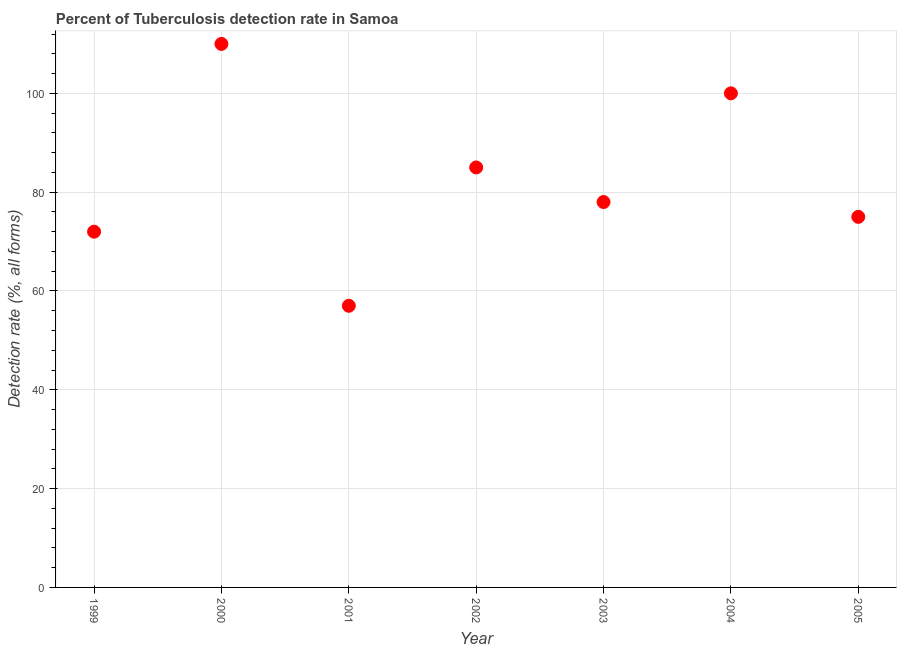What is the detection rate of tuberculosis in 2005?
Make the answer very short. 75. Across all years, what is the maximum detection rate of tuberculosis?
Provide a short and direct response. 110. Across all years, what is the minimum detection rate of tuberculosis?
Provide a short and direct response. 57. In which year was the detection rate of tuberculosis minimum?
Provide a short and direct response. 2001. What is the sum of the detection rate of tuberculosis?
Your answer should be compact. 577. What is the difference between the detection rate of tuberculosis in 1999 and 2002?
Make the answer very short. -13. What is the average detection rate of tuberculosis per year?
Offer a terse response. 82.43. Do a majority of the years between 2001 and 2000 (inclusive) have detection rate of tuberculosis greater than 44 %?
Offer a terse response. No. What is the ratio of the detection rate of tuberculosis in 2000 to that in 2002?
Offer a very short reply. 1.29. What is the difference between the highest and the second highest detection rate of tuberculosis?
Your response must be concise. 10. What is the difference between the highest and the lowest detection rate of tuberculosis?
Offer a very short reply. 53. How many dotlines are there?
Make the answer very short. 1. What is the difference between two consecutive major ticks on the Y-axis?
Your response must be concise. 20. Are the values on the major ticks of Y-axis written in scientific E-notation?
Keep it short and to the point. No. Does the graph contain grids?
Offer a terse response. Yes. What is the title of the graph?
Offer a terse response. Percent of Tuberculosis detection rate in Samoa. What is the label or title of the X-axis?
Your response must be concise. Year. What is the label or title of the Y-axis?
Give a very brief answer. Detection rate (%, all forms). What is the Detection rate (%, all forms) in 2000?
Make the answer very short. 110. What is the Detection rate (%, all forms) in 2002?
Your answer should be compact. 85. What is the Detection rate (%, all forms) in 2003?
Make the answer very short. 78. What is the Detection rate (%, all forms) in 2004?
Offer a very short reply. 100. What is the Detection rate (%, all forms) in 2005?
Your response must be concise. 75. What is the difference between the Detection rate (%, all forms) in 1999 and 2000?
Your answer should be very brief. -38. What is the difference between the Detection rate (%, all forms) in 1999 and 2001?
Offer a very short reply. 15. What is the difference between the Detection rate (%, all forms) in 1999 and 2003?
Your answer should be compact. -6. What is the difference between the Detection rate (%, all forms) in 1999 and 2004?
Offer a very short reply. -28. What is the difference between the Detection rate (%, all forms) in 1999 and 2005?
Your answer should be very brief. -3. What is the difference between the Detection rate (%, all forms) in 2000 and 2001?
Offer a terse response. 53. What is the difference between the Detection rate (%, all forms) in 2000 and 2002?
Provide a succinct answer. 25. What is the difference between the Detection rate (%, all forms) in 2001 and 2004?
Your answer should be compact. -43. What is the difference between the Detection rate (%, all forms) in 2002 and 2004?
Give a very brief answer. -15. What is the difference between the Detection rate (%, all forms) in 2002 and 2005?
Provide a short and direct response. 10. What is the difference between the Detection rate (%, all forms) in 2003 and 2005?
Provide a succinct answer. 3. What is the ratio of the Detection rate (%, all forms) in 1999 to that in 2000?
Provide a succinct answer. 0.66. What is the ratio of the Detection rate (%, all forms) in 1999 to that in 2001?
Provide a succinct answer. 1.26. What is the ratio of the Detection rate (%, all forms) in 1999 to that in 2002?
Your response must be concise. 0.85. What is the ratio of the Detection rate (%, all forms) in 1999 to that in 2003?
Offer a terse response. 0.92. What is the ratio of the Detection rate (%, all forms) in 1999 to that in 2004?
Give a very brief answer. 0.72. What is the ratio of the Detection rate (%, all forms) in 2000 to that in 2001?
Your answer should be compact. 1.93. What is the ratio of the Detection rate (%, all forms) in 2000 to that in 2002?
Offer a very short reply. 1.29. What is the ratio of the Detection rate (%, all forms) in 2000 to that in 2003?
Your answer should be very brief. 1.41. What is the ratio of the Detection rate (%, all forms) in 2000 to that in 2005?
Ensure brevity in your answer.  1.47. What is the ratio of the Detection rate (%, all forms) in 2001 to that in 2002?
Your response must be concise. 0.67. What is the ratio of the Detection rate (%, all forms) in 2001 to that in 2003?
Offer a very short reply. 0.73. What is the ratio of the Detection rate (%, all forms) in 2001 to that in 2004?
Give a very brief answer. 0.57. What is the ratio of the Detection rate (%, all forms) in 2001 to that in 2005?
Give a very brief answer. 0.76. What is the ratio of the Detection rate (%, all forms) in 2002 to that in 2003?
Make the answer very short. 1.09. What is the ratio of the Detection rate (%, all forms) in 2002 to that in 2004?
Provide a short and direct response. 0.85. What is the ratio of the Detection rate (%, all forms) in 2002 to that in 2005?
Give a very brief answer. 1.13. What is the ratio of the Detection rate (%, all forms) in 2003 to that in 2004?
Offer a very short reply. 0.78. What is the ratio of the Detection rate (%, all forms) in 2003 to that in 2005?
Offer a terse response. 1.04. What is the ratio of the Detection rate (%, all forms) in 2004 to that in 2005?
Give a very brief answer. 1.33. 